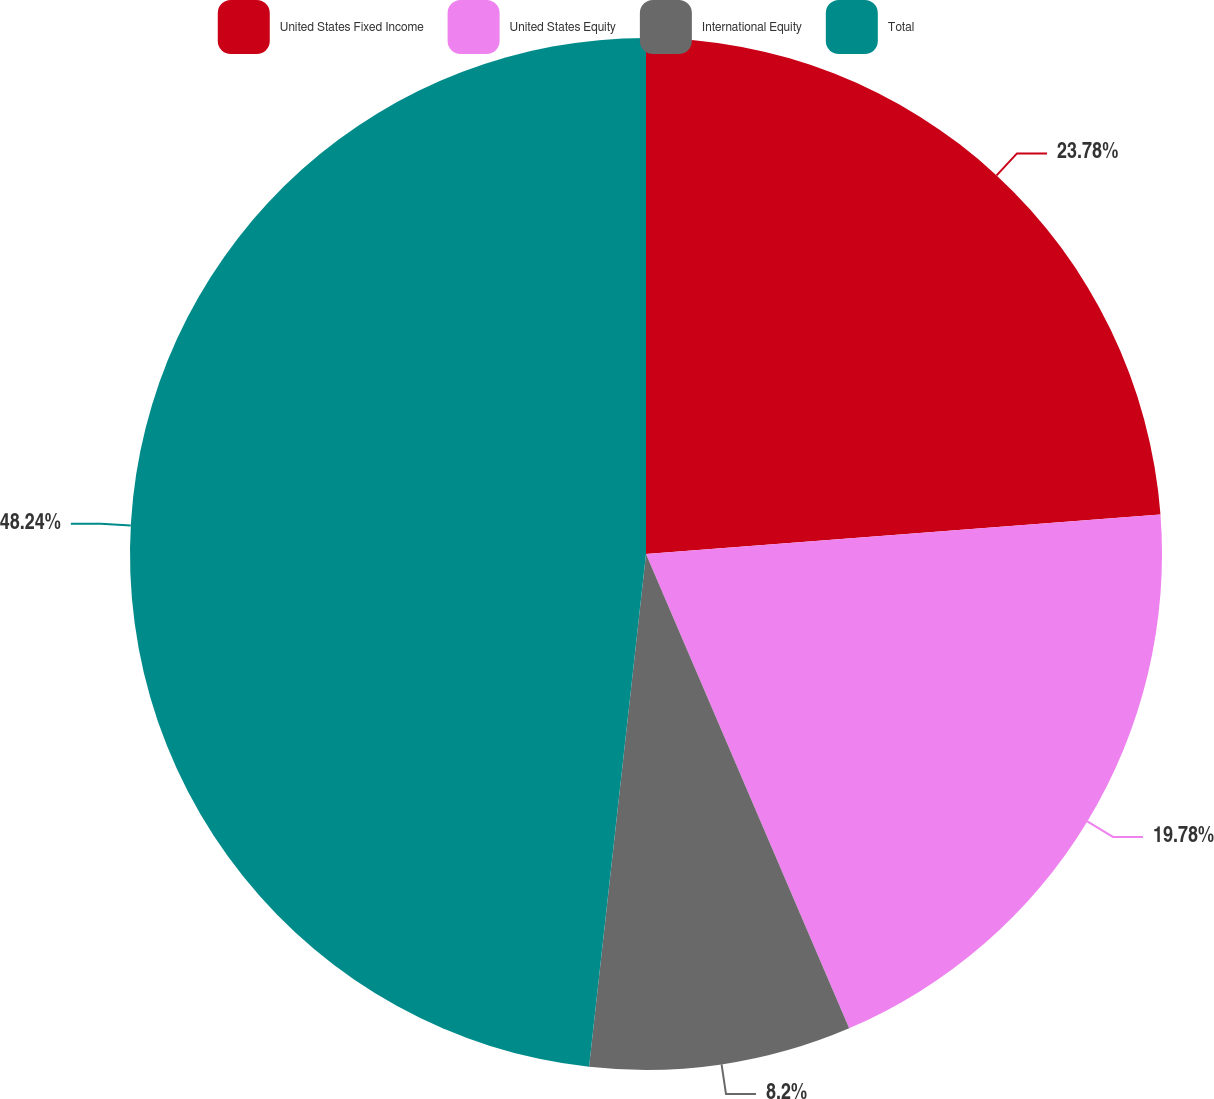<chart> <loc_0><loc_0><loc_500><loc_500><pie_chart><fcel>United States Fixed Income<fcel>United States Equity<fcel>International Equity<fcel>Total<nl><fcel>23.78%<fcel>19.78%<fcel>8.2%<fcel>48.24%<nl></chart> 